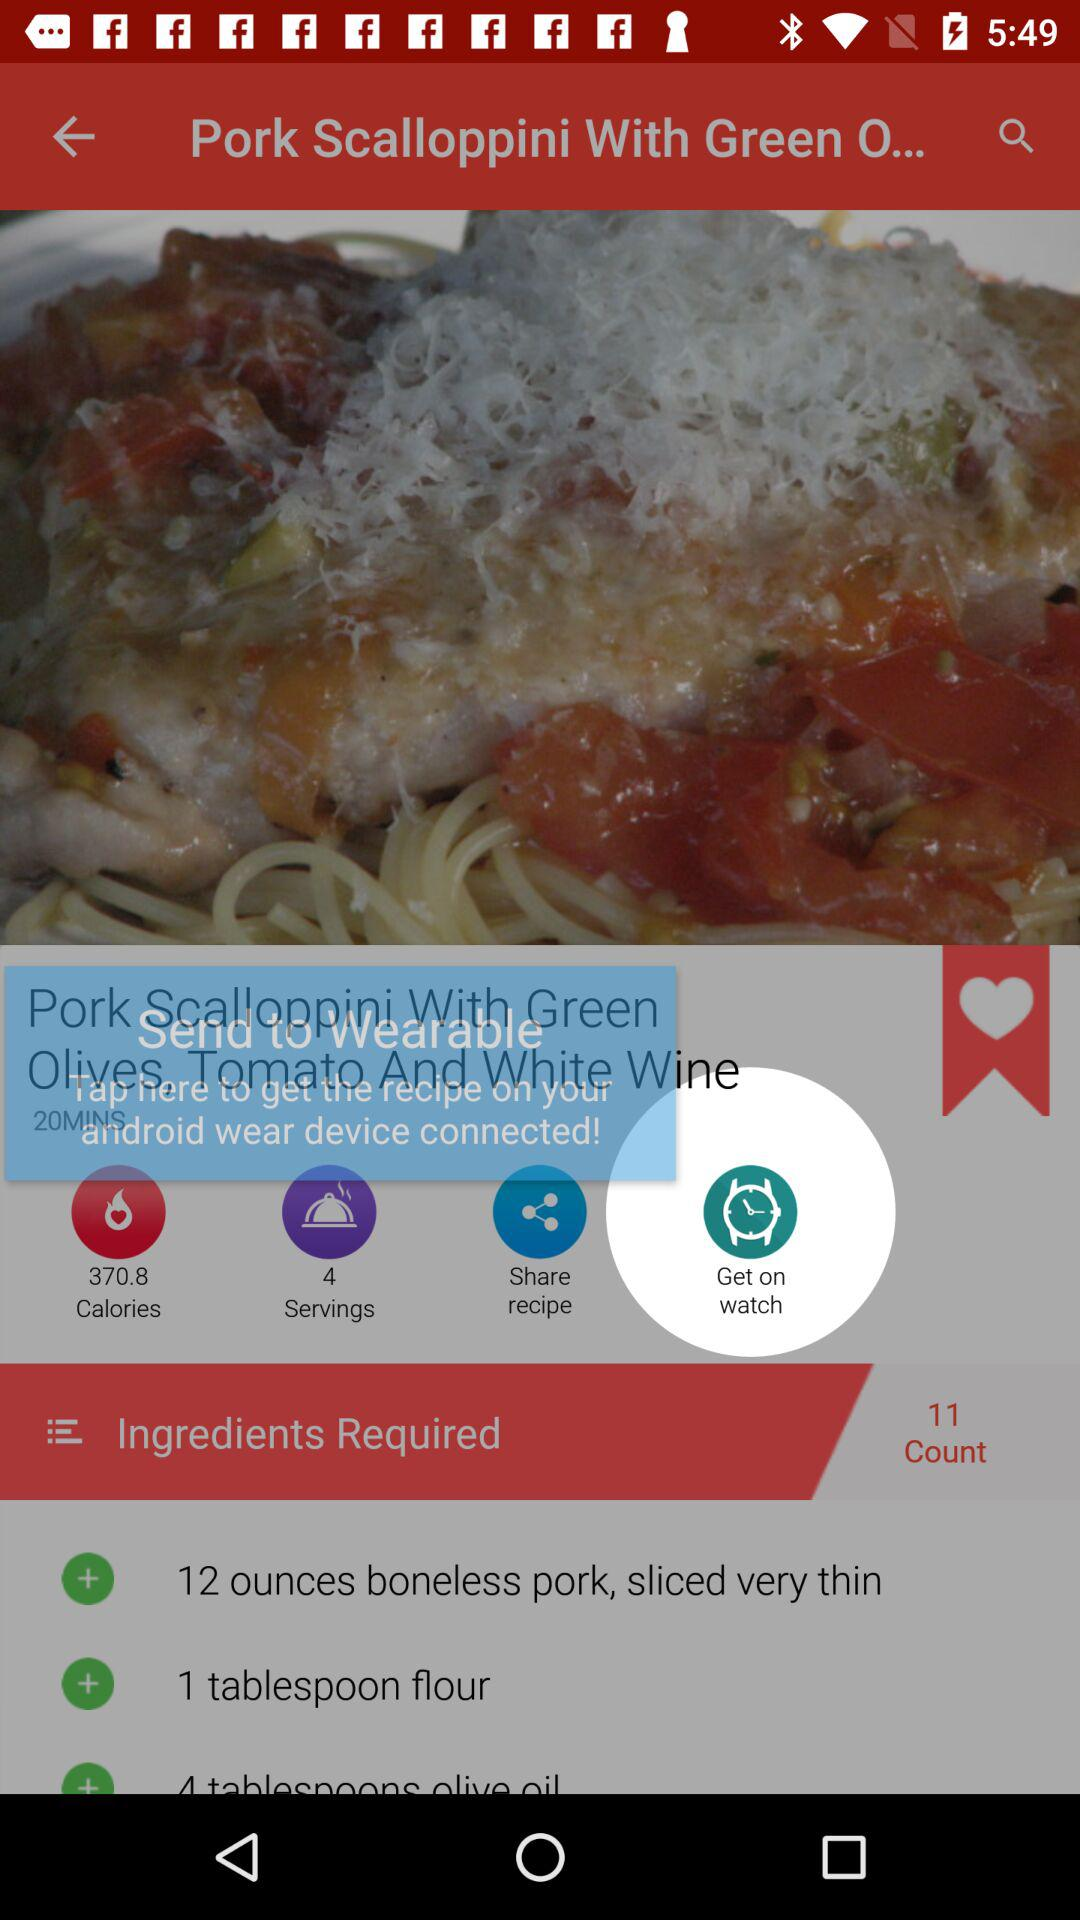How many servings of the dish are there? There are 4 servings. 